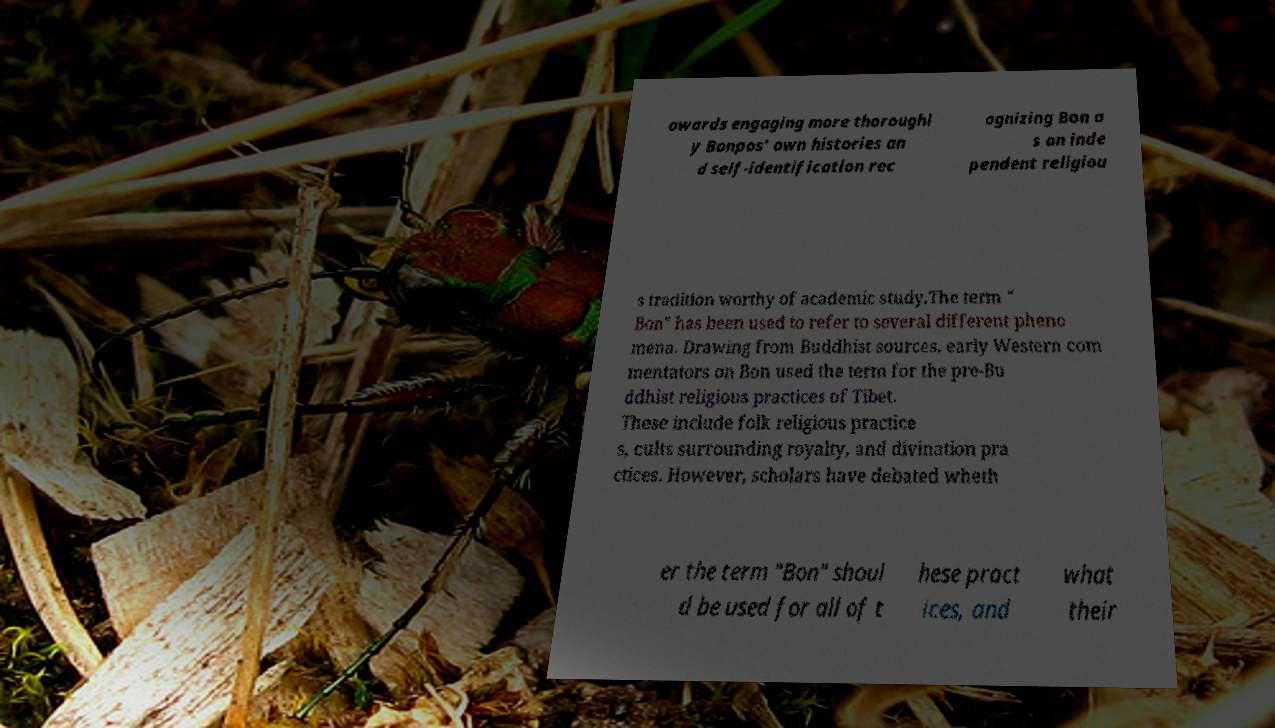For documentation purposes, I need the text within this image transcribed. Could you provide that? owards engaging more thoroughl y Bonpos' own histories an d self-identification rec ognizing Bon a s an inde pendent religiou s tradition worthy of academic study.The term " Bon" has been used to refer to several different pheno mena. Drawing from Buddhist sources, early Western com mentators on Bon used the term for the pre-Bu ddhist religious practices of Tibet. These include folk religious practice s, cults surrounding royalty, and divination pra ctices. However, scholars have debated wheth er the term "Bon" shoul d be used for all of t hese pract ices, and what their 